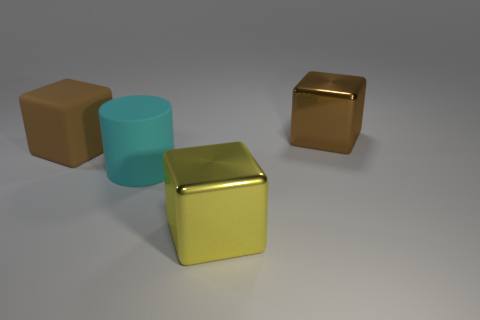Is the big brown block that is right of the big brown rubber object made of the same material as the cyan cylinder?
Your answer should be compact. No. Is the number of yellow blocks that are on the left side of the cyan object the same as the number of big metallic things behind the large brown metallic cube?
Your answer should be very brief. Yes. There is another large cube that is the same color as the rubber block; what material is it?
Ensure brevity in your answer.  Metal. There is a big matte thing that is right of the large brown matte object; how many large brown metallic cubes are behind it?
Offer a very short reply. 1. There is a object to the left of the big cyan matte cylinder; does it have the same color as the shiny thing that is in front of the large cylinder?
Give a very brief answer. No. What is the material of the yellow block that is the same size as the cyan rubber cylinder?
Your response must be concise. Metal. The metallic object on the right side of the metallic thing that is left of the large brown metallic cube that is to the right of the cyan matte object is what shape?
Provide a short and direct response. Cube. There is a yellow thing that is the same size as the matte block; what shape is it?
Your answer should be compact. Cube. What number of big brown rubber cubes are on the right side of the big brown thing that is behind the cube on the left side of the big yellow object?
Offer a very short reply. 0. Are there more yellow metallic things to the left of the cyan matte cylinder than big rubber cylinders that are behind the big matte cube?
Provide a succinct answer. No. 